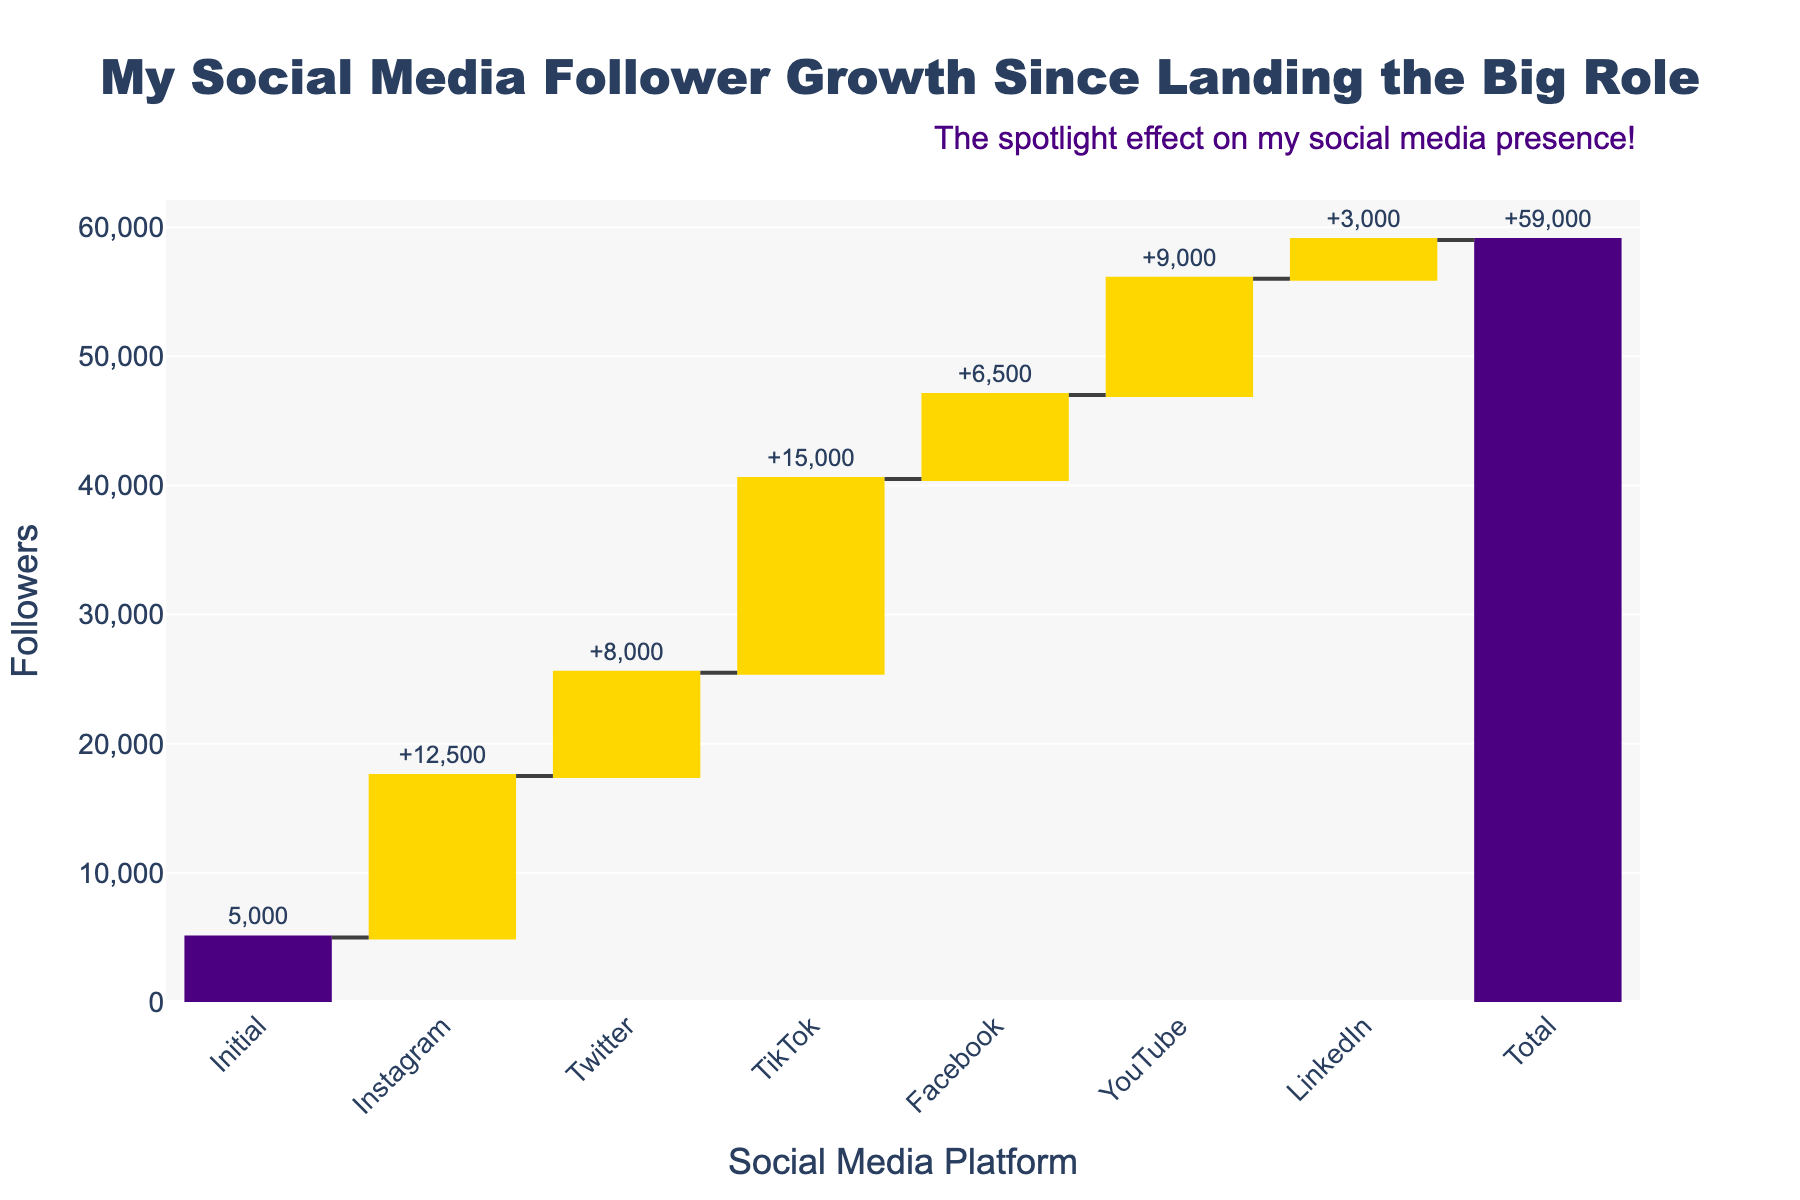Which social media platform had the highest increase in followers? By looking at the waterfall chart, we can identify that TikTok has the highest bar indicating the largest follower increase among the platforms shown.
Answer: TikTok How many platforms are displayed in the chart? The x-axis of the chart shows the number of platforms, along with the 'Initial' and 'Total' labels. Counting these, we get seven platforms plus two additional labels (Initial, Total).
Answer: 9 What was the total increase in followers across all platforms? The 'Total' label at the end of the waterfall chart shows the overall increase after considering all platforms.
Answer: 59,000 How much did Instagram contribute to the overall follower increase? The chart shows Instagram's contribution with a bar that has a label of '+12,500', indicating its specific share in the total increase.
Answer: 12,500 Which platform showed the smallest increase in followers? By comparing all the bars representing each platform's follower increase, LinkedIn has the smallest bar labeled '+3,000'.
Answer: LinkedIn What is the cumulative increase in followers across Instagram, TikTok, and Facebook? Adding the follower increases for Instagram (12,500), TikTok (15,000), and Facebook (6,500) gives: 12,500 + 15,000 + 6,500 = 34,000
Answer: 34,000 How does the follower increase on YouTube compare to Twitter? Looking at the respective bars, YouTube has an increase of 9,000 followers, while Twitter's increase is 8,000 followers. By comparing the two, YouTube's increase is 1,000 followers more than Twitter.
Answer: YouTube increased by 1,000 more than Twitter What is the difference in follower increase between TikTok and LinkedIn? Identifying the bars for TikTok and LinkedIn and noting their values, TikTok increased by 15,000 while LinkedIn increased by 3,000. The difference is 15,000 - 3,000 = 12,000.
Answer: 12,000 How does the follower increase on Facebook and YouTube combined compare to TikTok? Adding Facebook's increases (6,500) to YouTube's increases (9,000) gives 6,500 + 9,000 = 15,500, which can be compared to TikTok's increase of 15,000. Hence, 15,500 - 15,000 = 500.
Answer: Combined increase is 500 more than TikTok What is the initial number of followers before the new followers were gained? The 'Initial' label at the start of the waterfall chart shows the starting followers number before the increase.
Answer: 5,000 